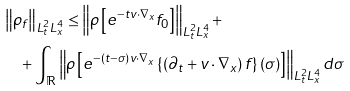Convert formula to latex. <formula><loc_0><loc_0><loc_500><loc_500>& \left \| \rho _ { f } \right \| _ { L ^ { 2 } _ { t } L ^ { 4 } _ { x } } \leq \left \| \rho \left [ e ^ { - t v \cdot \nabla _ { x } } f _ { 0 } \right ] \right \| _ { L ^ { 2 } _ { t } L ^ { 4 } _ { x } } + \\ & \quad + \int _ { \mathbb { R } } \left \| \rho \left [ e ^ { - ( t - \sigma ) v \cdot \nabla _ { x } } \left \{ \left ( \partial _ { t } + v \cdot \nabla _ { x } \right ) f \right \} ( \sigma ) \right ] \right \| _ { L ^ { 2 } _ { t } L ^ { 4 } _ { x } } d \sigma</formula> 